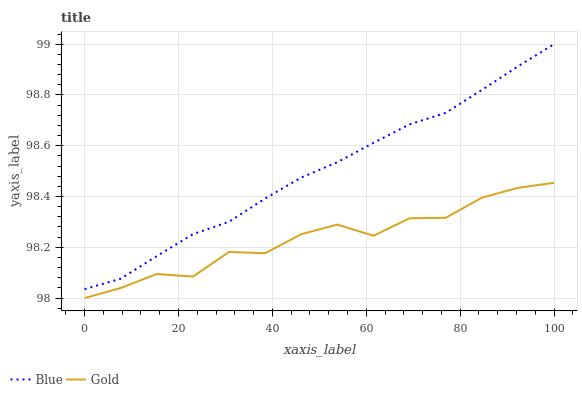Does Gold have the minimum area under the curve?
Answer yes or no. Yes. Does Blue have the maximum area under the curve?
Answer yes or no. Yes. Does Gold have the maximum area under the curve?
Answer yes or no. No. Is Blue the smoothest?
Answer yes or no. Yes. Is Gold the roughest?
Answer yes or no. Yes. Is Gold the smoothest?
Answer yes or no. No. Does Gold have the lowest value?
Answer yes or no. Yes. Does Blue have the highest value?
Answer yes or no. Yes. Does Gold have the highest value?
Answer yes or no. No. Is Gold less than Blue?
Answer yes or no. Yes. Is Blue greater than Gold?
Answer yes or no. Yes. Does Gold intersect Blue?
Answer yes or no. No. 